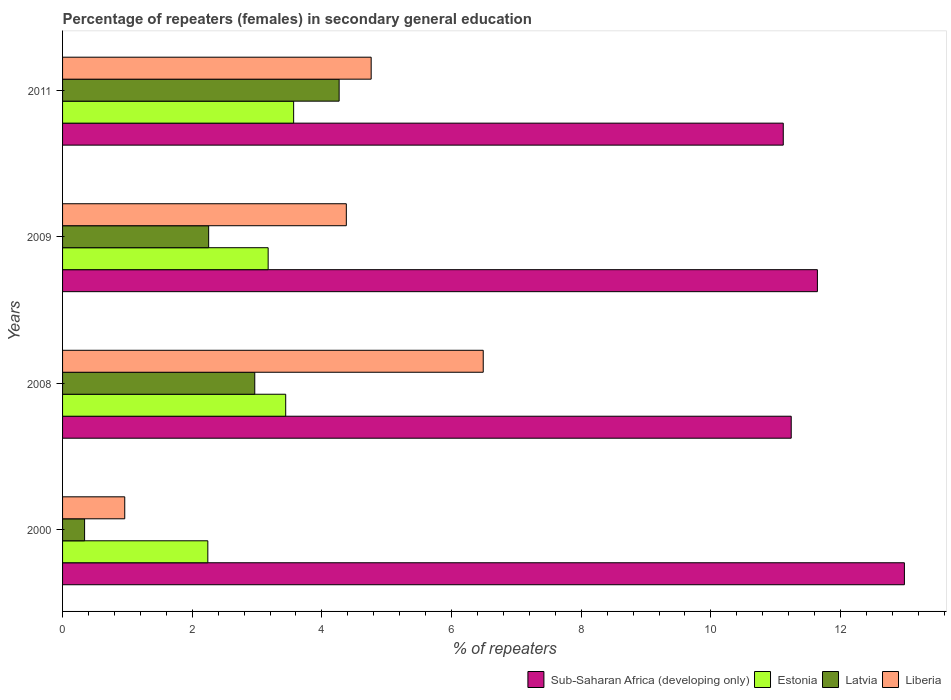How many different coloured bars are there?
Offer a terse response. 4. How many bars are there on the 3rd tick from the top?
Ensure brevity in your answer.  4. How many bars are there on the 1st tick from the bottom?
Keep it short and to the point. 4. What is the label of the 4th group of bars from the top?
Offer a very short reply. 2000. In how many cases, is the number of bars for a given year not equal to the number of legend labels?
Your answer should be compact. 0. What is the percentage of female repeaters in Sub-Saharan Africa (developing only) in 2008?
Give a very brief answer. 11.24. Across all years, what is the maximum percentage of female repeaters in Latvia?
Give a very brief answer. 4.27. Across all years, what is the minimum percentage of female repeaters in Sub-Saharan Africa (developing only)?
Offer a terse response. 11.12. In which year was the percentage of female repeaters in Latvia maximum?
Provide a short and direct response. 2011. In which year was the percentage of female repeaters in Estonia minimum?
Give a very brief answer. 2000. What is the total percentage of female repeaters in Liberia in the graph?
Your answer should be very brief. 16.58. What is the difference between the percentage of female repeaters in Sub-Saharan Africa (developing only) in 2008 and that in 2009?
Make the answer very short. -0.4. What is the difference between the percentage of female repeaters in Estonia in 2011 and the percentage of female repeaters in Liberia in 2000?
Offer a terse response. 2.61. What is the average percentage of female repeaters in Liberia per year?
Offer a very short reply. 4.15. In the year 2011, what is the difference between the percentage of female repeaters in Liberia and percentage of female repeaters in Sub-Saharan Africa (developing only)?
Provide a short and direct response. -6.36. What is the ratio of the percentage of female repeaters in Sub-Saharan Africa (developing only) in 2008 to that in 2011?
Offer a terse response. 1.01. Is the percentage of female repeaters in Sub-Saharan Africa (developing only) in 2000 less than that in 2009?
Your answer should be compact. No. What is the difference between the highest and the second highest percentage of female repeaters in Estonia?
Make the answer very short. 0.12. What is the difference between the highest and the lowest percentage of female repeaters in Liberia?
Ensure brevity in your answer.  5.53. In how many years, is the percentage of female repeaters in Sub-Saharan Africa (developing only) greater than the average percentage of female repeaters in Sub-Saharan Africa (developing only) taken over all years?
Offer a terse response. 1. Is it the case that in every year, the sum of the percentage of female repeaters in Liberia and percentage of female repeaters in Latvia is greater than the sum of percentage of female repeaters in Sub-Saharan Africa (developing only) and percentage of female repeaters in Estonia?
Your answer should be compact. No. What does the 3rd bar from the top in 2009 represents?
Offer a very short reply. Estonia. What does the 1st bar from the bottom in 2009 represents?
Ensure brevity in your answer.  Sub-Saharan Africa (developing only). What is the difference between two consecutive major ticks on the X-axis?
Keep it short and to the point. 2. Are the values on the major ticks of X-axis written in scientific E-notation?
Give a very brief answer. No. Does the graph contain grids?
Your answer should be compact. No. Where does the legend appear in the graph?
Offer a terse response. Bottom right. How many legend labels are there?
Your response must be concise. 4. How are the legend labels stacked?
Your response must be concise. Horizontal. What is the title of the graph?
Make the answer very short. Percentage of repeaters (females) in secondary general education. What is the label or title of the X-axis?
Give a very brief answer. % of repeaters. What is the label or title of the Y-axis?
Provide a succinct answer. Years. What is the % of repeaters in Sub-Saharan Africa (developing only) in 2000?
Your answer should be compact. 12.98. What is the % of repeaters in Estonia in 2000?
Provide a succinct answer. 2.24. What is the % of repeaters in Latvia in 2000?
Make the answer very short. 0.34. What is the % of repeaters of Liberia in 2000?
Ensure brevity in your answer.  0.96. What is the % of repeaters in Sub-Saharan Africa (developing only) in 2008?
Provide a succinct answer. 11.24. What is the % of repeaters in Estonia in 2008?
Your answer should be very brief. 3.44. What is the % of repeaters of Latvia in 2008?
Offer a very short reply. 2.96. What is the % of repeaters of Liberia in 2008?
Your answer should be compact. 6.49. What is the % of repeaters of Sub-Saharan Africa (developing only) in 2009?
Your answer should be compact. 11.64. What is the % of repeaters in Estonia in 2009?
Give a very brief answer. 3.17. What is the % of repeaters of Latvia in 2009?
Offer a terse response. 2.25. What is the % of repeaters of Liberia in 2009?
Your answer should be very brief. 4.38. What is the % of repeaters in Sub-Saharan Africa (developing only) in 2011?
Your answer should be very brief. 11.12. What is the % of repeaters in Estonia in 2011?
Your response must be concise. 3.56. What is the % of repeaters in Latvia in 2011?
Your answer should be very brief. 4.27. What is the % of repeaters in Liberia in 2011?
Offer a terse response. 4.76. Across all years, what is the maximum % of repeaters in Sub-Saharan Africa (developing only)?
Provide a succinct answer. 12.98. Across all years, what is the maximum % of repeaters in Estonia?
Ensure brevity in your answer.  3.56. Across all years, what is the maximum % of repeaters of Latvia?
Ensure brevity in your answer.  4.27. Across all years, what is the maximum % of repeaters in Liberia?
Keep it short and to the point. 6.49. Across all years, what is the minimum % of repeaters of Sub-Saharan Africa (developing only)?
Make the answer very short. 11.12. Across all years, what is the minimum % of repeaters of Estonia?
Offer a very short reply. 2.24. Across all years, what is the minimum % of repeaters in Latvia?
Make the answer very short. 0.34. Across all years, what is the minimum % of repeaters in Liberia?
Ensure brevity in your answer.  0.96. What is the total % of repeaters in Sub-Saharan Africa (developing only) in the graph?
Keep it short and to the point. 46.98. What is the total % of repeaters in Estonia in the graph?
Offer a very short reply. 12.42. What is the total % of repeaters in Latvia in the graph?
Provide a short and direct response. 9.82. What is the total % of repeaters of Liberia in the graph?
Keep it short and to the point. 16.58. What is the difference between the % of repeaters of Sub-Saharan Africa (developing only) in 2000 and that in 2008?
Your answer should be very brief. 1.75. What is the difference between the % of repeaters in Estonia in 2000 and that in 2008?
Provide a short and direct response. -1.2. What is the difference between the % of repeaters of Latvia in 2000 and that in 2008?
Ensure brevity in your answer.  -2.62. What is the difference between the % of repeaters in Liberia in 2000 and that in 2008?
Your answer should be compact. -5.53. What is the difference between the % of repeaters of Sub-Saharan Africa (developing only) in 2000 and that in 2009?
Your answer should be compact. 1.34. What is the difference between the % of repeaters of Estonia in 2000 and that in 2009?
Your answer should be compact. -0.93. What is the difference between the % of repeaters of Latvia in 2000 and that in 2009?
Your answer should be compact. -1.91. What is the difference between the % of repeaters of Liberia in 2000 and that in 2009?
Provide a short and direct response. -3.42. What is the difference between the % of repeaters in Sub-Saharan Africa (developing only) in 2000 and that in 2011?
Make the answer very short. 1.87. What is the difference between the % of repeaters of Estonia in 2000 and that in 2011?
Your answer should be compact. -1.32. What is the difference between the % of repeaters of Latvia in 2000 and that in 2011?
Give a very brief answer. -3.93. What is the difference between the % of repeaters of Liberia in 2000 and that in 2011?
Ensure brevity in your answer.  -3.8. What is the difference between the % of repeaters in Sub-Saharan Africa (developing only) in 2008 and that in 2009?
Your response must be concise. -0.4. What is the difference between the % of repeaters in Estonia in 2008 and that in 2009?
Provide a succinct answer. 0.27. What is the difference between the % of repeaters of Latvia in 2008 and that in 2009?
Provide a short and direct response. 0.71. What is the difference between the % of repeaters of Liberia in 2008 and that in 2009?
Make the answer very short. 2.11. What is the difference between the % of repeaters in Sub-Saharan Africa (developing only) in 2008 and that in 2011?
Keep it short and to the point. 0.12. What is the difference between the % of repeaters of Estonia in 2008 and that in 2011?
Your response must be concise. -0.12. What is the difference between the % of repeaters of Latvia in 2008 and that in 2011?
Keep it short and to the point. -1.3. What is the difference between the % of repeaters in Liberia in 2008 and that in 2011?
Provide a short and direct response. 1.73. What is the difference between the % of repeaters in Sub-Saharan Africa (developing only) in 2009 and that in 2011?
Give a very brief answer. 0.53. What is the difference between the % of repeaters of Estonia in 2009 and that in 2011?
Your response must be concise. -0.39. What is the difference between the % of repeaters of Latvia in 2009 and that in 2011?
Give a very brief answer. -2.01. What is the difference between the % of repeaters in Liberia in 2009 and that in 2011?
Offer a terse response. -0.38. What is the difference between the % of repeaters in Sub-Saharan Africa (developing only) in 2000 and the % of repeaters in Estonia in 2008?
Ensure brevity in your answer.  9.54. What is the difference between the % of repeaters of Sub-Saharan Africa (developing only) in 2000 and the % of repeaters of Latvia in 2008?
Make the answer very short. 10.02. What is the difference between the % of repeaters in Sub-Saharan Africa (developing only) in 2000 and the % of repeaters in Liberia in 2008?
Your answer should be very brief. 6.5. What is the difference between the % of repeaters in Estonia in 2000 and the % of repeaters in Latvia in 2008?
Offer a terse response. -0.72. What is the difference between the % of repeaters of Estonia in 2000 and the % of repeaters of Liberia in 2008?
Provide a short and direct response. -4.25. What is the difference between the % of repeaters in Latvia in 2000 and the % of repeaters in Liberia in 2008?
Your response must be concise. -6.15. What is the difference between the % of repeaters in Sub-Saharan Africa (developing only) in 2000 and the % of repeaters in Estonia in 2009?
Keep it short and to the point. 9.81. What is the difference between the % of repeaters of Sub-Saharan Africa (developing only) in 2000 and the % of repeaters of Latvia in 2009?
Provide a succinct answer. 10.73. What is the difference between the % of repeaters of Sub-Saharan Africa (developing only) in 2000 and the % of repeaters of Liberia in 2009?
Give a very brief answer. 8.61. What is the difference between the % of repeaters in Estonia in 2000 and the % of repeaters in Latvia in 2009?
Your response must be concise. -0.01. What is the difference between the % of repeaters of Estonia in 2000 and the % of repeaters of Liberia in 2009?
Give a very brief answer. -2.14. What is the difference between the % of repeaters of Latvia in 2000 and the % of repeaters of Liberia in 2009?
Make the answer very short. -4.04. What is the difference between the % of repeaters in Sub-Saharan Africa (developing only) in 2000 and the % of repeaters in Estonia in 2011?
Keep it short and to the point. 9.42. What is the difference between the % of repeaters of Sub-Saharan Africa (developing only) in 2000 and the % of repeaters of Latvia in 2011?
Your answer should be compact. 8.72. What is the difference between the % of repeaters of Sub-Saharan Africa (developing only) in 2000 and the % of repeaters of Liberia in 2011?
Ensure brevity in your answer.  8.22. What is the difference between the % of repeaters of Estonia in 2000 and the % of repeaters of Latvia in 2011?
Your answer should be compact. -2.03. What is the difference between the % of repeaters of Estonia in 2000 and the % of repeaters of Liberia in 2011?
Offer a terse response. -2.52. What is the difference between the % of repeaters of Latvia in 2000 and the % of repeaters of Liberia in 2011?
Your response must be concise. -4.42. What is the difference between the % of repeaters of Sub-Saharan Africa (developing only) in 2008 and the % of repeaters of Estonia in 2009?
Provide a succinct answer. 8.07. What is the difference between the % of repeaters of Sub-Saharan Africa (developing only) in 2008 and the % of repeaters of Latvia in 2009?
Keep it short and to the point. 8.99. What is the difference between the % of repeaters of Sub-Saharan Africa (developing only) in 2008 and the % of repeaters of Liberia in 2009?
Make the answer very short. 6.86. What is the difference between the % of repeaters of Estonia in 2008 and the % of repeaters of Latvia in 2009?
Provide a short and direct response. 1.19. What is the difference between the % of repeaters of Estonia in 2008 and the % of repeaters of Liberia in 2009?
Your response must be concise. -0.93. What is the difference between the % of repeaters of Latvia in 2008 and the % of repeaters of Liberia in 2009?
Keep it short and to the point. -1.41. What is the difference between the % of repeaters of Sub-Saharan Africa (developing only) in 2008 and the % of repeaters of Estonia in 2011?
Keep it short and to the point. 7.67. What is the difference between the % of repeaters in Sub-Saharan Africa (developing only) in 2008 and the % of repeaters in Latvia in 2011?
Your answer should be very brief. 6.97. What is the difference between the % of repeaters of Sub-Saharan Africa (developing only) in 2008 and the % of repeaters of Liberia in 2011?
Your answer should be very brief. 6.48. What is the difference between the % of repeaters of Estonia in 2008 and the % of repeaters of Latvia in 2011?
Offer a terse response. -0.82. What is the difference between the % of repeaters of Estonia in 2008 and the % of repeaters of Liberia in 2011?
Provide a short and direct response. -1.32. What is the difference between the % of repeaters in Latvia in 2008 and the % of repeaters in Liberia in 2011?
Offer a very short reply. -1.8. What is the difference between the % of repeaters of Sub-Saharan Africa (developing only) in 2009 and the % of repeaters of Estonia in 2011?
Ensure brevity in your answer.  8.08. What is the difference between the % of repeaters of Sub-Saharan Africa (developing only) in 2009 and the % of repeaters of Latvia in 2011?
Keep it short and to the point. 7.38. What is the difference between the % of repeaters in Sub-Saharan Africa (developing only) in 2009 and the % of repeaters in Liberia in 2011?
Ensure brevity in your answer.  6.88. What is the difference between the % of repeaters of Estonia in 2009 and the % of repeaters of Latvia in 2011?
Your response must be concise. -1.09. What is the difference between the % of repeaters in Estonia in 2009 and the % of repeaters in Liberia in 2011?
Offer a very short reply. -1.59. What is the difference between the % of repeaters of Latvia in 2009 and the % of repeaters of Liberia in 2011?
Keep it short and to the point. -2.51. What is the average % of repeaters in Sub-Saharan Africa (developing only) per year?
Offer a very short reply. 11.75. What is the average % of repeaters in Estonia per year?
Your response must be concise. 3.1. What is the average % of repeaters in Latvia per year?
Provide a short and direct response. 2.46. What is the average % of repeaters in Liberia per year?
Ensure brevity in your answer.  4.15. In the year 2000, what is the difference between the % of repeaters of Sub-Saharan Africa (developing only) and % of repeaters of Estonia?
Keep it short and to the point. 10.74. In the year 2000, what is the difference between the % of repeaters of Sub-Saharan Africa (developing only) and % of repeaters of Latvia?
Offer a terse response. 12.64. In the year 2000, what is the difference between the % of repeaters in Sub-Saharan Africa (developing only) and % of repeaters in Liberia?
Offer a terse response. 12.03. In the year 2000, what is the difference between the % of repeaters of Estonia and % of repeaters of Latvia?
Provide a succinct answer. 1.9. In the year 2000, what is the difference between the % of repeaters of Estonia and % of repeaters of Liberia?
Your answer should be compact. 1.28. In the year 2000, what is the difference between the % of repeaters of Latvia and % of repeaters of Liberia?
Your answer should be very brief. -0.62. In the year 2008, what is the difference between the % of repeaters in Sub-Saharan Africa (developing only) and % of repeaters in Estonia?
Your response must be concise. 7.8. In the year 2008, what is the difference between the % of repeaters of Sub-Saharan Africa (developing only) and % of repeaters of Latvia?
Your answer should be very brief. 8.27. In the year 2008, what is the difference between the % of repeaters of Sub-Saharan Africa (developing only) and % of repeaters of Liberia?
Ensure brevity in your answer.  4.75. In the year 2008, what is the difference between the % of repeaters of Estonia and % of repeaters of Latvia?
Your response must be concise. 0.48. In the year 2008, what is the difference between the % of repeaters in Estonia and % of repeaters in Liberia?
Provide a succinct answer. -3.05. In the year 2008, what is the difference between the % of repeaters in Latvia and % of repeaters in Liberia?
Give a very brief answer. -3.52. In the year 2009, what is the difference between the % of repeaters of Sub-Saharan Africa (developing only) and % of repeaters of Estonia?
Ensure brevity in your answer.  8.47. In the year 2009, what is the difference between the % of repeaters in Sub-Saharan Africa (developing only) and % of repeaters in Latvia?
Make the answer very short. 9.39. In the year 2009, what is the difference between the % of repeaters of Sub-Saharan Africa (developing only) and % of repeaters of Liberia?
Keep it short and to the point. 7.27. In the year 2009, what is the difference between the % of repeaters in Estonia and % of repeaters in Latvia?
Keep it short and to the point. 0.92. In the year 2009, what is the difference between the % of repeaters in Estonia and % of repeaters in Liberia?
Provide a short and direct response. -1.21. In the year 2009, what is the difference between the % of repeaters in Latvia and % of repeaters in Liberia?
Ensure brevity in your answer.  -2.12. In the year 2011, what is the difference between the % of repeaters of Sub-Saharan Africa (developing only) and % of repeaters of Estonia?
Your response must be concise. 7.55. In the year 2011, what is the difference between the % of repeaters in Sub-Saharan Africa (developing only) and % of repeaters in Latvia?
Make the answer very short. 6.85. In the year 2011, what is the difference between the % of repeaters in Sub-Saharan Africa (developing only) and % of repeaters in Liberia?
Your response must be concise. 6.36. In the year 2011, what is the difference between the % of repeaters of Estonia and % of repeaters of Latvia?
Give a very brief answer. -0.7. In the year 2011, what is the difference between the % of repeaters in Estonia and % of repeaters in Liberia?
Your answer should be very brief. -1.2. In the year 2011, what is the difference between the % of repeaters of Latvia and % of repeaters of Liberia?
Keep it short and to the point. -0.49. What is the ratio of the % of repeaters of Sub-Saharan Africa (developing only) in 2000 to that in 2008?
Provide a short and direct response. 1.16. What is the ratio of the % of repeaters of Estonia in 2000 to that in 2008?
Offer a terse response. 0.65. What is the ratio of the % of repeaters of Latvia in 2000 to that in 2008?
Make the answer very short. 0.11. What is the ratio of the % of repeaters of Liberia in 2000 to that in 2008?
Offer a very short reply. 0.15. What is the ratio of the % of repeaters of Sub-Saharan Africa (developing only) in 2000 to that in 2009?
Offer a terse response. 1.12. What is the ratio of the % of repeaters of Estonia in 2000 to that in 2009?
Ensure brevity in your answer.  0.71. What is the ratio of the % of repeaters in Latvia in 2000 to that in 2009?
Offer a terse response. 0.15. What is the ratio of the % of repeaters in Liberia in 2000 to that in 2009?
Ensure brevity in your answer.  0.22. What is the ratio of the % of repeaters of Sub-Saharan Africa (developing only) in 2000 to that in 2011?
Offer a terse response. 1.17. What is the ratio of the % of repeaters in Estonia in 2000 to that in 2011?
Offer a very short reply. 0.63. What is the ratio of the % of repeaters of Latvia in 2000 to that in 2011?
Give a very brief answer. 0.08. What is the ratio of the % of repeaters of Liberia in 2000 to that in 2011?
Provide a succinct answer. 0.2. What is the ratio of the % of repeaters of Sub-Saharan Africa (developing only) in 2008 to that in 2009?
Your response must be concise. 0.97. What is the ratio of the % of repeaters of Estonia in 2008 to that in 2009?
Keep it short and to the point. 1.09. What is the ratio of the % of repeaters in Latvia in 2008 to that in 2009?
Your answer should be compact. 1.32. What is the ratio of the % of repeaters in Liberia in 2008 to that in 2009?
Give a very brief answer. 1.48. What is the ratio of the % of repeaters in Estonia in 2008 to that in 2011?
Give a very brief answer. 0.97. What is the ratio of the % of repeaters in Latvia in 2008 to that in 2011?
Provide a succinct answer. 0.69. What is the ratio of the % of repeaters of Liberia in 2008 to that in 2011?
Provide a succinct answer. 1.36. What is the ratio of the % of repeaters of Sub-Saharan Africa (developing only) in 2009 to that in 2011?
Offer a terse response. 1.05. What is the ratio of the % of repeaters in Estonia in 2009 to that in 2011?
Provide a short and direct response. 0.89. What is the ratio of the % of repeaters in Latvia in 2009 to that in 2011?
Your response must be concise. 0.53. What is the ratio of the % of repeaters in Liberia in 2009 to that in 2011?
Your answer should be compact. 0.92. What is the difference between the highest and the second highest % of repeaters of Sub-Saharan Africa (developing only)?
Give a very brief answer. 1.34. What is the difference between the highest and the second highest % of repeaters in Estonia?
Give a very brief answer. 0.12. What is the difference between the highest and the second highest % of repeaters of Latvia?
Ensure brevity in your answer.  1.3. What is the difference between the highest and the second highest % of repeaters in Liberia?
Your answer should be very brief. 1.73. What is the difference between the highest and the lowest % of repeaters in Sub-Saharan Africa (developing only)?
Make the answer very short. 1.87. What is the difference between the highest and the lowest % of repeaters in Estonia?
Provide a short and direct response. 1.32. What is the difference between the highest and the lowest % of repeaters in Latvia?
Your answer should be compact. 3.93. What is the difference between the highest and the lowest % of repeaters in Liberia?
Ensure brevity in your answer.  5.53. 